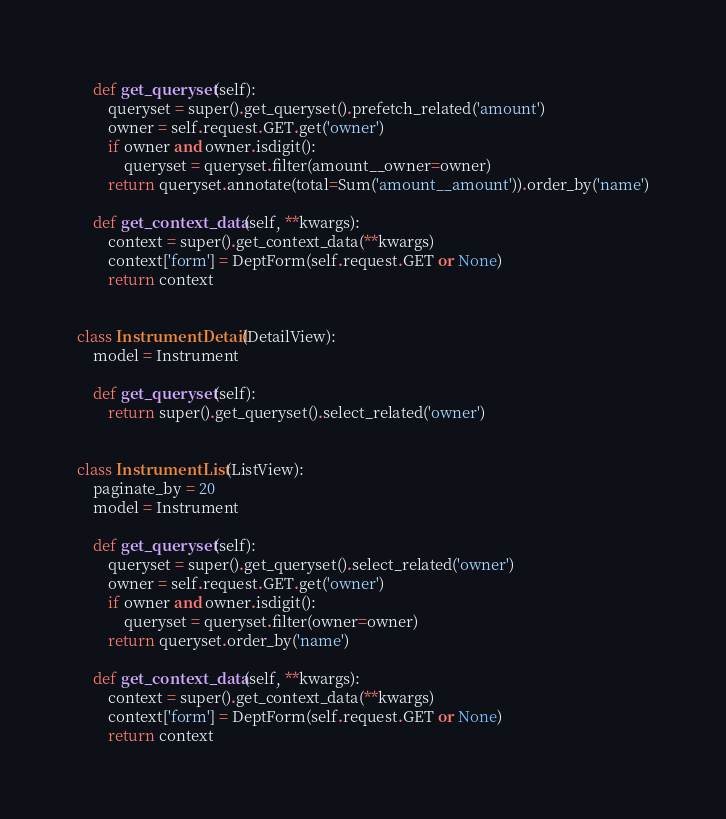<code> <loc_0><loc_0><loc_500><loc_500><_Python_>
    def get_queryset(self):
        queryset = super().get_queryset().prefetch_related('amount')
        owner = self.request.GET.get('owner')
        if owner and owner.isdigit():
            queryset = queryset.filter(amount__owner=owner)
        return queryset.annotate(total=Sum('amount__amount')).order_by('name')

    def get_context_data(self, **kwargs):
        context = super().get_context_data(**kwargs)
        context['form'] = DeptForm(self.request.GET or None)
        return context


class InstrumentDetail(DetailView):
    model = Instrument

    def get_queryset(self):
        return super().get_queryset().select_related('owner')


class InstrumentList(ListView):
    paginate_by = 20
    model = Instrument

    def get_queryset(self):
        queryset = super().get_queryset().select_related('owner')
        owner = self.request.GET.get('owner')
        if owner and owner.isdigit():
            queryset = queryset.filter(owner=owner)
        return queryset.order_by('name')

    def get_context_data(self, **kwargs):
        context = super().get_context_data(**kwargs)
        context['form'] = DeptForm(self.request.GET or None)
        return context
</code> 